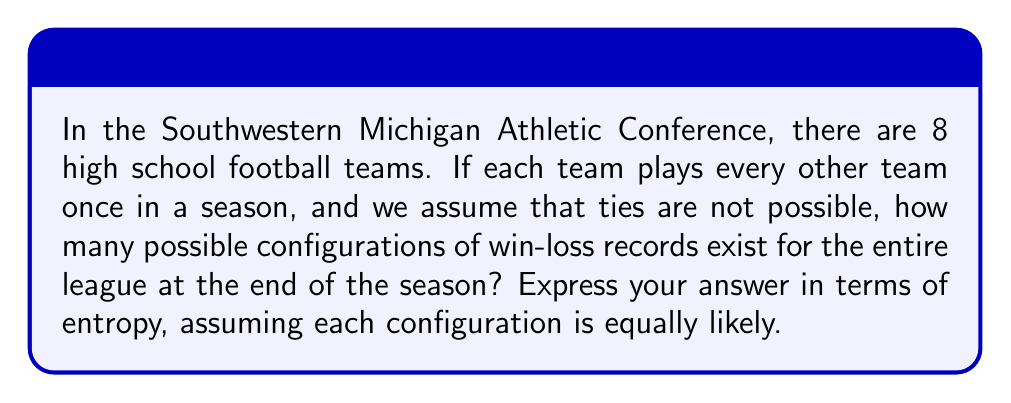Provide a solution to this math problem. Let's approach this step-by-step:

1) First, we need to calculate the total number of games played in the season:
   Each team plays 7 games (against every other team once)
   Total games = $(8 * 7) / 2 = 28$ games

2) Each game has two possible outcomes (win for team A or win for team B)
   So, for 28 games, there are $2^{28}$ possible outcomes

3) In statistical mechanics, entropy is related to the number of microstates (in this case, possible configurations) by the Boltzmann formula:

   $S = k_B \ln \Omega$

   Where $S$ is entropy, $k_B$ is Boltzmann's constant, and $\Omega$ is the number of microstates

4) In this case, $\Omega = 2^{28}$

5) Substituting into the entropy formula:

   $S = k_B \ln (2^{28})$

6) Using the logarithm property $\ln (a^b) = b \ln a$:

   $S = k_B (28 \ln 2)$

7) We can leave the answer in terms of $k_B$ as it's a constant
Answer: $S = 28k_B \ln 2$ 